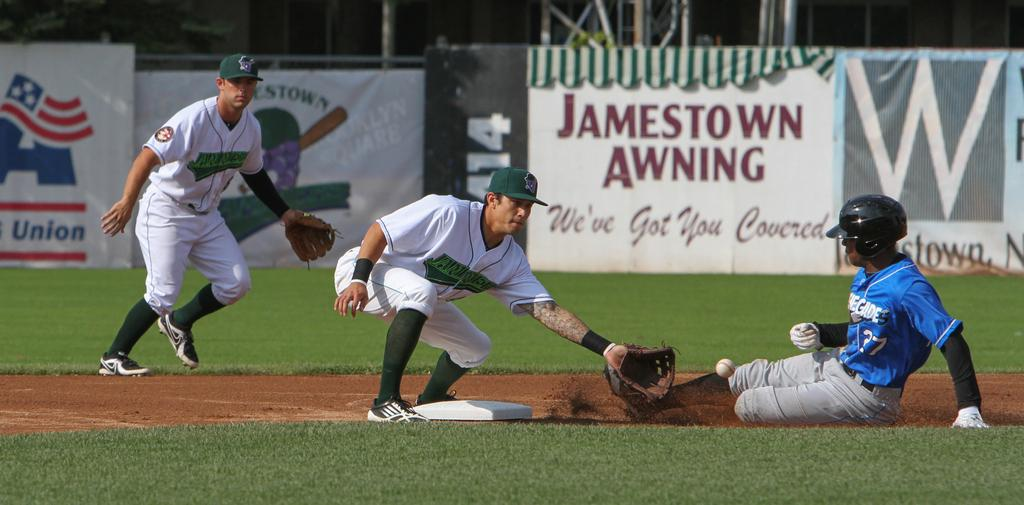Provide a one-sentence caption for the provided image. Baseball player sliding into second base below a Jamestown Awning sign. 